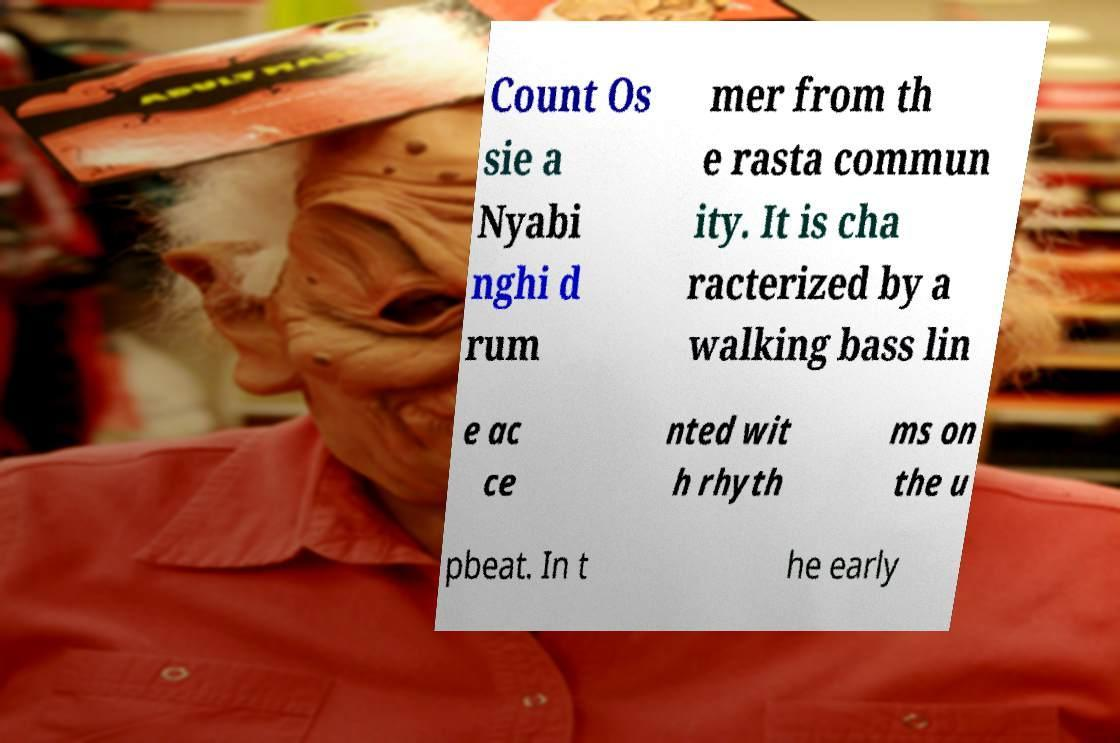Can you read and provide the text displayed in the image?This photo seems to have some interesting text. Can you extract and type it out for me? Count Os sie a Nyabi nghi d rum mer from th e rasta commun ity. It is cha racterized by a walking bass lin e ac ce nted wit h rhyth ms on the u pbeat. In t he early 